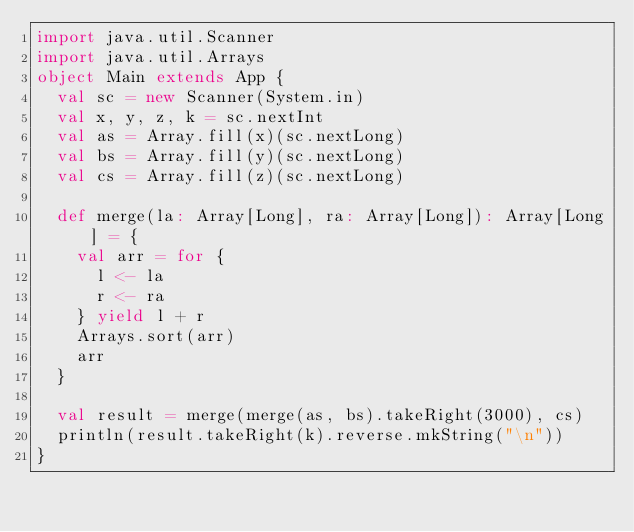Convert code to text. <code><loc_0><loc_0><loc_500><loc_500><_Scala_>import java.util.Scanner
import java.util.Arrays
object Main extends App {
  val sc = new Scanner(System.in)
  val x, y, z, k = sc.nextInt
  val as = Array.fill(x)(sc.nextLong)
  val bs = Array.fill(y)(sc.nextLong)
  val cs = Array.fill(z)(sc.nextLong)

  def merge(la: Array[Long], ra: Array[Long]): Array[Long] = {
    val arr = for {
      l <- la
      r <- ra
    } yield l + r
    Arrays.sort(arr)
    arr
  }

  val result = merge(merge(as, bs).takeRight(3000), cs)
  println(result.takeRight(k).reverse.mkString("\n"))
}</code> 